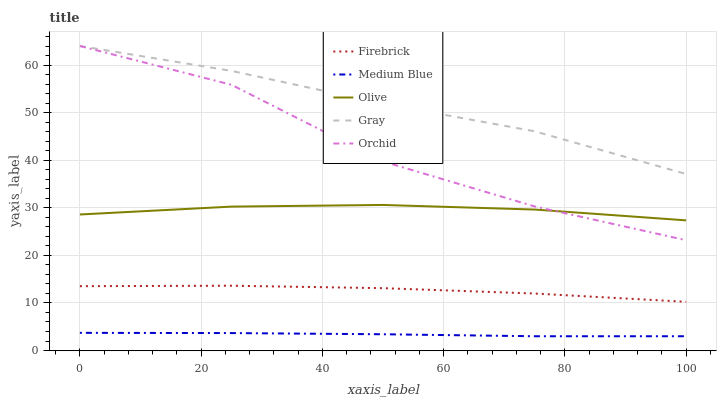Does Medium Blue have the minimum area under the curve?
Answer yes or no. Yes. Does Gray have the maximum area under the curve?
Answer yes or no. Yes. Does Firebrick have the minimum area under the curve?
Answer yes or no. No. Does Firebrick have the maximum area under the curve?
Answer yes or no. No. Is Medium Blue the smoothest?
Answer yes or no. Yes. Is Orchid the roughest?
Answer yes or no. Yes. Is Gray the smoothest?
Answer yes or no. No. Is Gray the roughest?
Answer yes or no. No. Does Medium Blue have the lowest value?
Answer yes or no. Yes. Does Firebrick have the lowest value?
Answer yes or no. No. Does Orchid have the highest value?
Answer yes or no. Yes. Does Firebrick have the highest value?
Answer yes or no. No. Is Firebrick less than Olive?
Answer yes or no. Yes. Is Olive greater than Medium Blue?
Answer yes or no. Yes. Does Orchid intersect Olive?
Answer yes or no. Yes. Is Orchid less than Olive?
Answer yes or no. No. Is Orchid greater than Olive?
Answer yes or no. No. Does Firebrick intersect Olive?
Answer yes or no. No. 